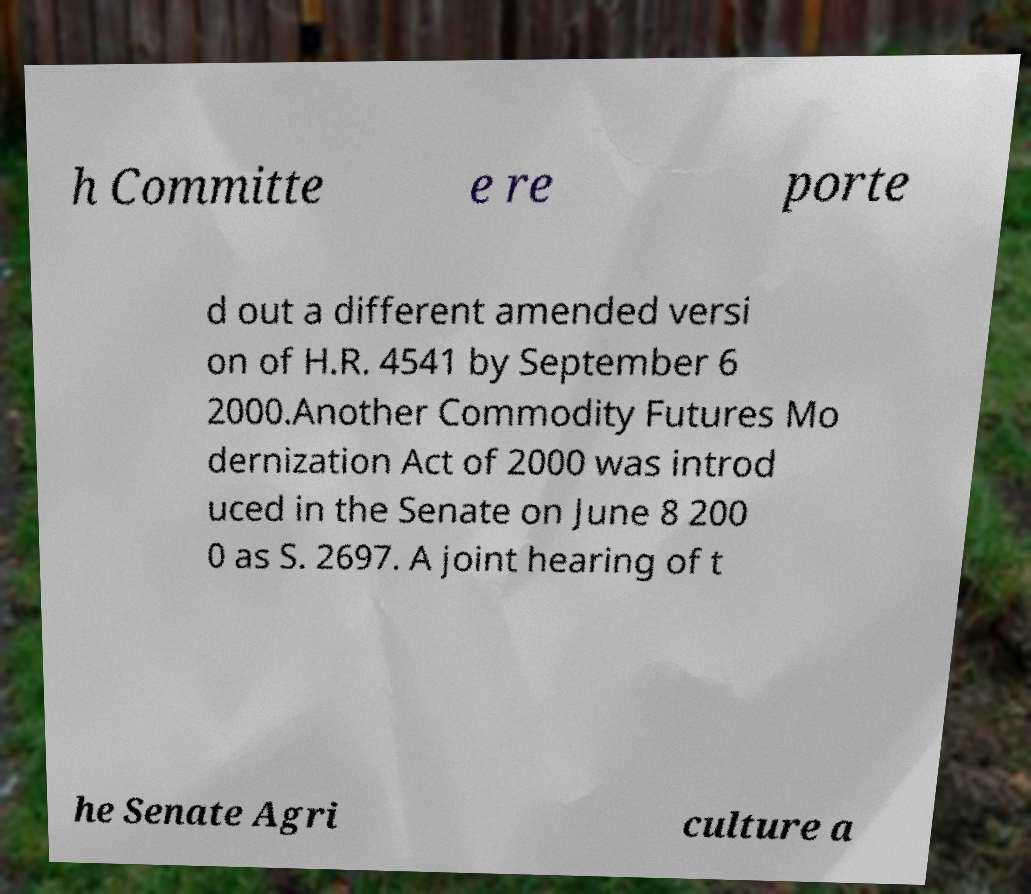What messages or text are displayed in this image? I need them in a readable, typed format. h Committe e re porte d out a different amended versi on of H.R. 4541 by September 6 2000.Another Commodity Futures Mo dernization Act of 2000 was introd uced in the Senate on June 8 200 0 as S. 2697. A joint hearing of t he Senate Agri culture a 